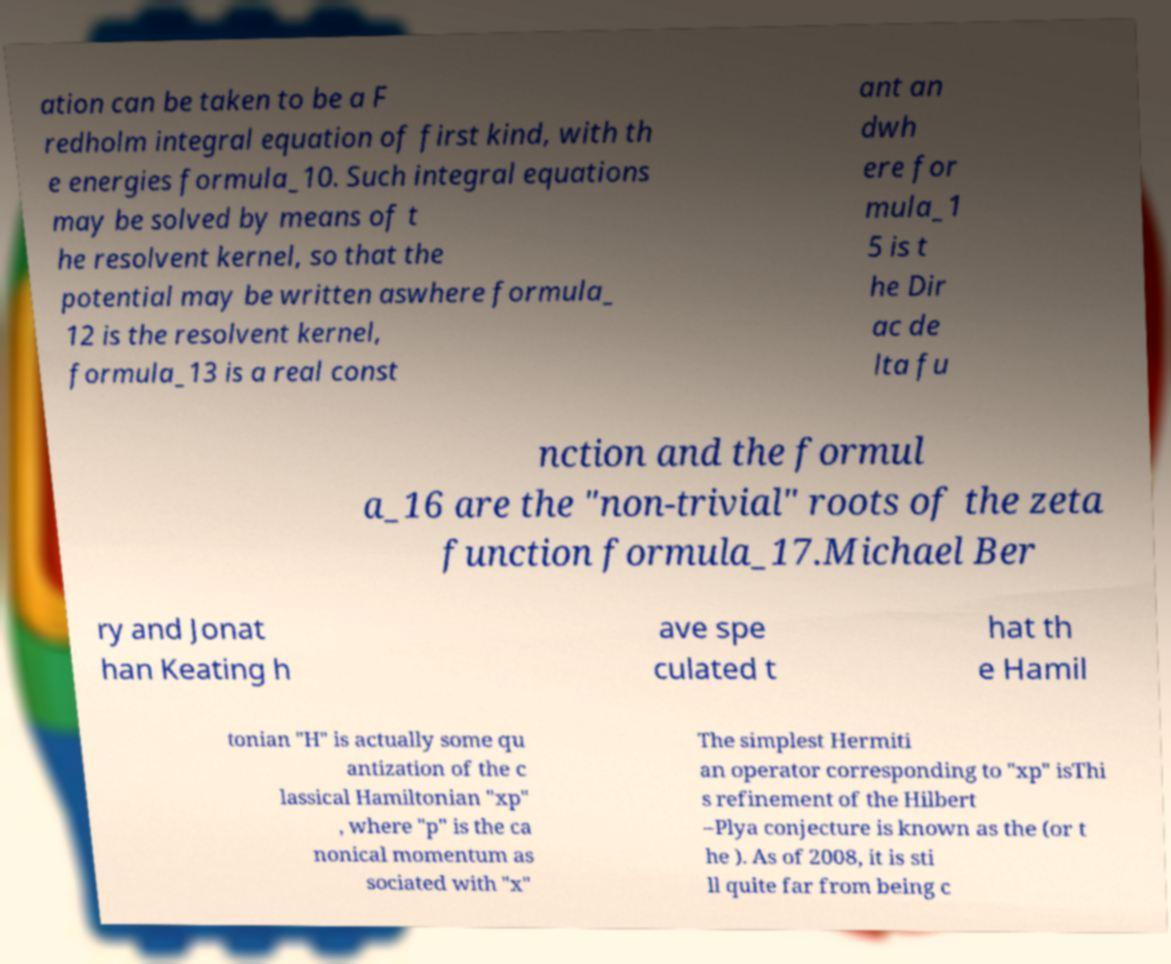There's text embedded in this image that I need extracted. Can you transcribe it verbatim? ation can be taken to be a F redholm integral equation of first kind, with th e energies formula_10. Such integral equations may be solved by means of t he resolvent kernel, so that the potential may be written aswhere formula_ 12 is the resolvent kernel, formula_13 is a real const ant an dwh ere for mula_1 5 is t he Dir ac de lta fu nction and the formul a_16 are the "non-trivial" roots of the zeta function formula_17.Michael Ber ry and Jonat han Keating h ave spe culated t hat th e Hamil tonian "H" is actually some qu antization of the c lassical Hamiltonian "xp" , where "p" is the ca nonical momentum as sociated with "x" The simplest Hermiti an operator corresponding to "xp" isThi s refinement of the Hilbert –Plya conjecture is known as the (or t he ). As of 2008, it is sti ll quite far from being c 